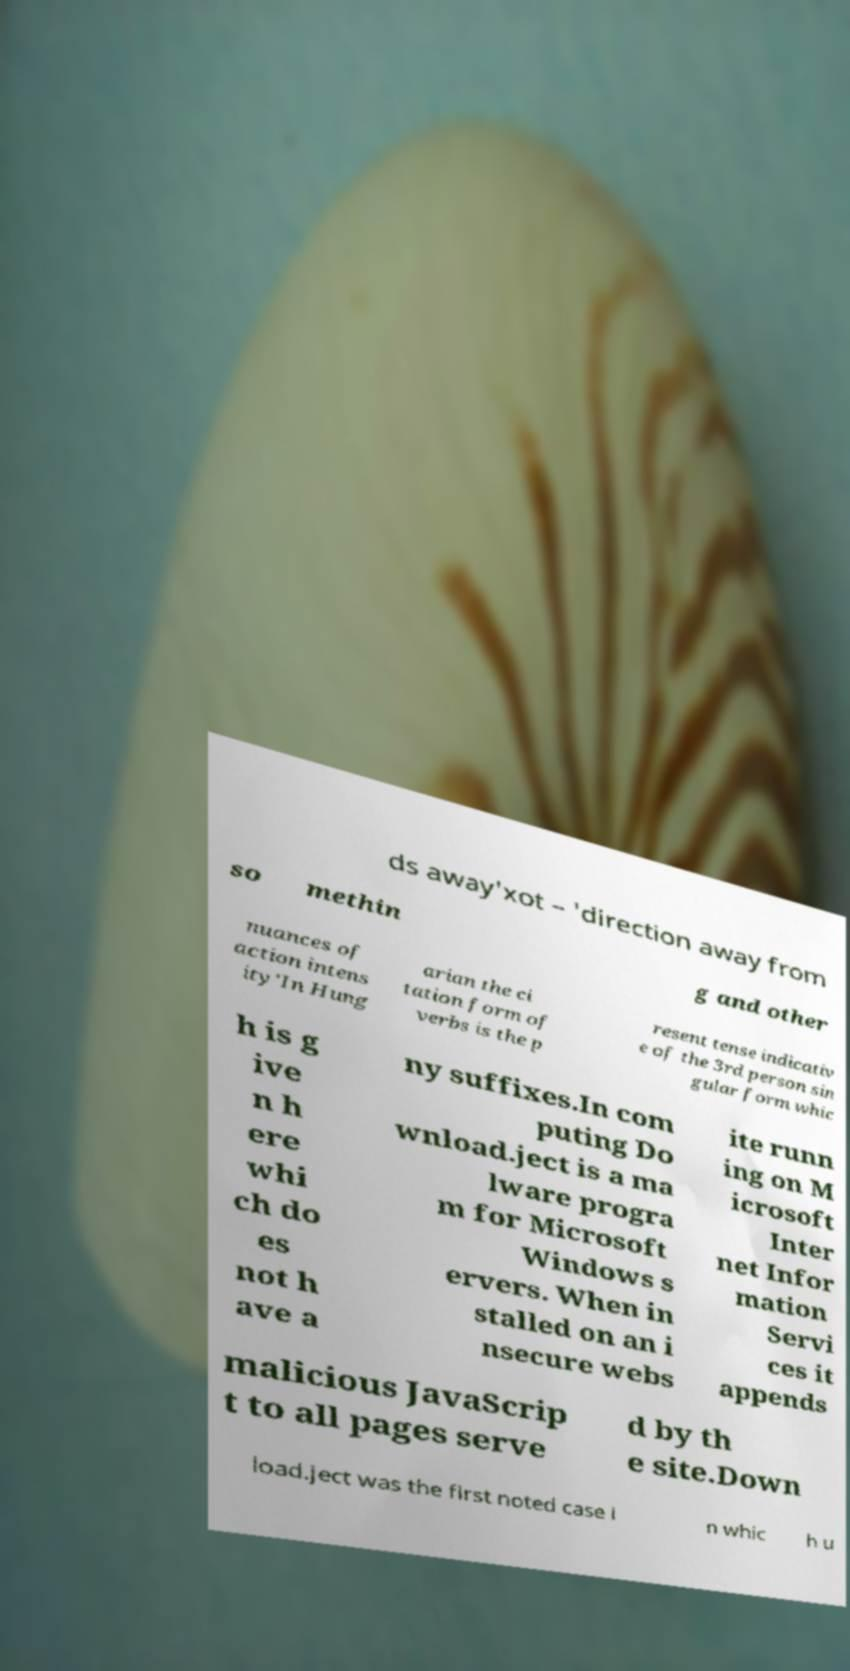Please identify and transcribe the text found in this image. ds away'xot – 'direction away from so methin g and other nuances of action intens ity'In Hung arian the ci tation form of verbs is the p resent tense indicativ e of the 3rd person sin gular form whic h is g ive n h ere whi ch do es not h ave a ny suffixes.In com puting Do wnload.ject is a ma lware progra m for Microsoft Windows s ervers. When in stalled on an i nsecure webs ite runn ing on M icrosoft Inter net Infor mation Servi ces it appends malicious JavaScrip t to all pages serve d by th e site.Down load.ject was the first noted case i n whic h u 